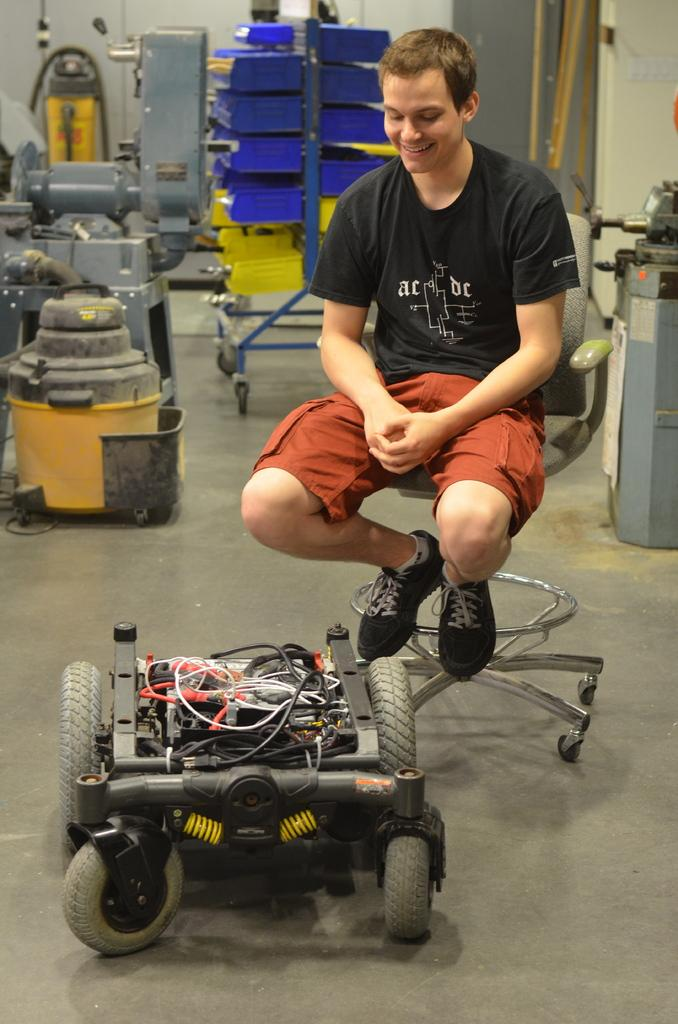What is on the floor in the image? There is a small vehicle on the floor. What is the man in the image doing? The man is sitting on a chair. What can be seen in the background of the image? There are machines, a trolley, other objects, and a wall in the background. Can you see a knife being used in the image? There is no knife present in the image. Is there a store visible in the background of the image? There is no store visible in the image; it features a man sitting on a chair, a small vehicle on the floor, and various objects and machines in the background. 